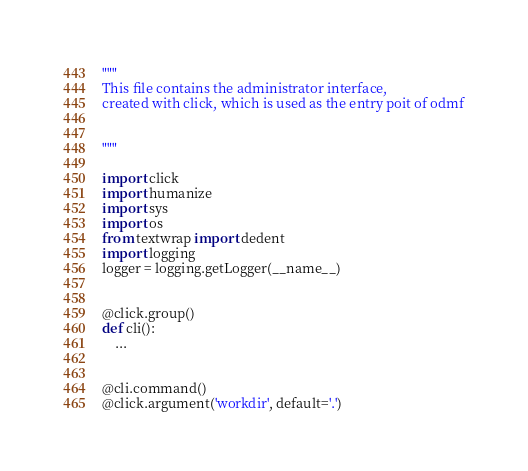<code> <loc_0><loc_0><loc_500><loc_500><_Python_>"""
This file contains the administrator interface,
created with click, which is used as the entry poit of odmf


"""

import click
import humanize
import sys
import os
from textwrap import dedent
import logging
logger = logging.getLogger(__name__)


@click.group()
def cli():
    ...


@cli.command()
@click.argument('workdir', default='.')</code> 